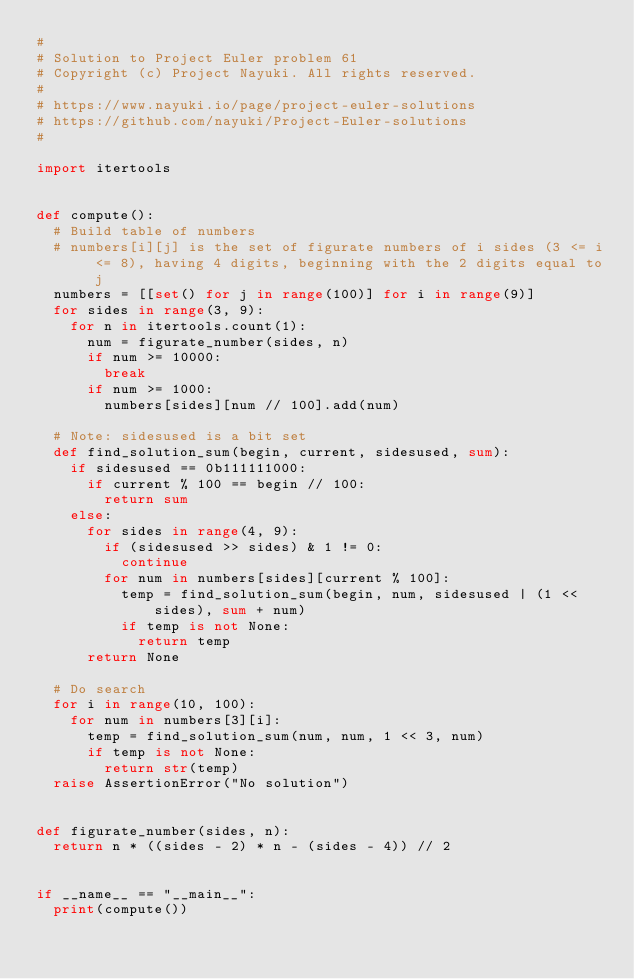<code> <loc_0><loc_0><loc_500><loc_500><_Python_># 
# Solution to Project Euler problem 61
# Copyright (c) Project Nayuki. All rights reserved.
# 
# https://www.nayuki.io/page/project-euler-solutions
# https://github.com/nayuki/Project-Euler-solutions
# 

import itertools


def compute():
	# Build table of numbers
	# numbers[i][j] is the set of figurate numbers of i sides (3 <= i <= 8), having 4 digits, beginning with the 2 digits equal to j
	numbers = [[set() for j in range(100)] for i in range(9)]
	for sides in range(3, 9):
		for n in itertools.count(1):
			num = figurate_number(sides, n)
			if num >= 10000:
				break
			if num >= 1000:
				numbers[sides][num // 100].add(num)
	
	# Note: sidesused is a bit set
	def find_solution_sum(begin, current, sidesused, sum):
		if sidesused == 0b111111000:
			if current % 100 == begin // 100:
				return sum
		else:
			for sides in range(4, 9):
				if (sidesused >> sides) & 1 != 0:
					continue
				for num in numbers[sides][current % 100]:
					temp = find_solution_sum(begin, num, sidesused | (1 << sides), sum + num)
					if temp is not None:
						return temp
			return None
	
	# Do search
	for i in range(10, 100):
		for num in numbers[3][i]:
			temp = find_solution_sum(num, num, 1 << 3, num)
			if temp is not None:
				return str(temp)
	raise AssertionError("No solution")


def figurate_number(sides, n):
	return n * ((sides - 2) * n - (sides - 4)) // 2


if __name__ == "__main__":
	print(compute())
</code> 